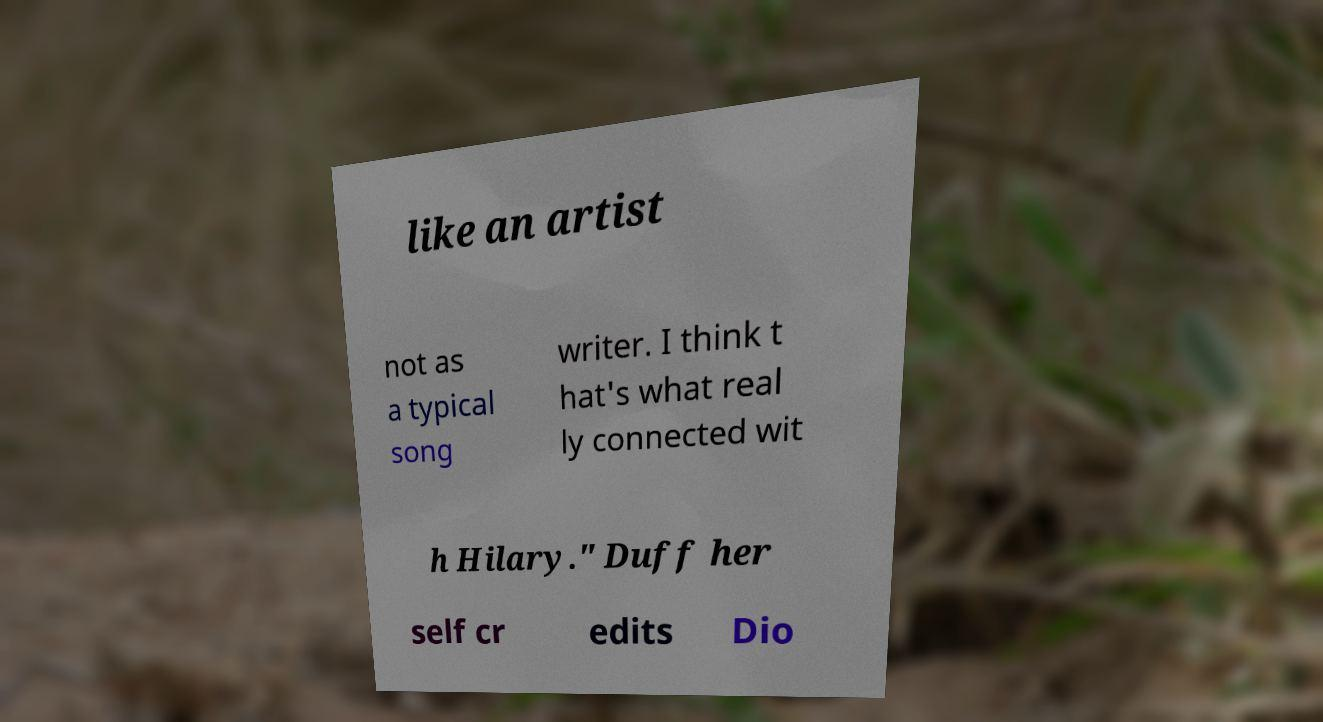What messages or text are displayed in this image? I need them in a readable, typed format. like an artist not as a typical song writer. I think t hat's what real ly connected wit h Hilary." Duff her self cr edits Dio 